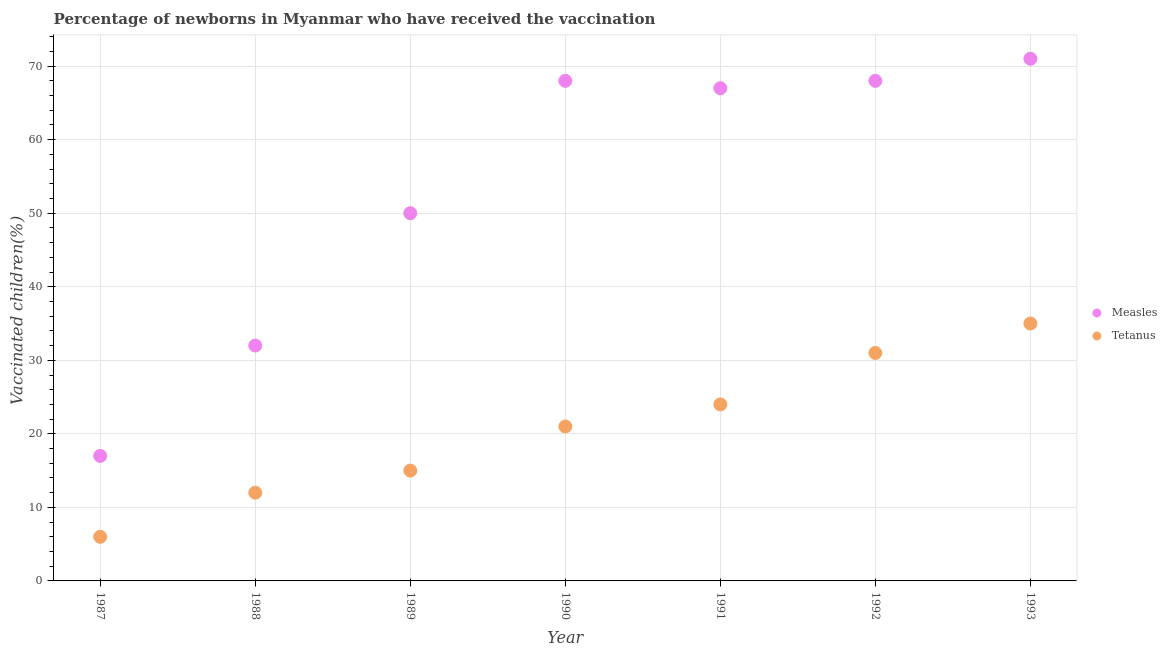How many different coloured dotlines are there?
Provide a short and direct response. 2. Is the number of dotlines equal to the number of legend labels?
Your response must be concise. Yes. What is the percentage of newborns who received vaccination for tetanus in 1987?
Provide a short and direct response. 6. Across all years, what is the maximum percentage of newborns who received vaccination for tetanus?
Offer a very short reply. 35. Across all years, what is the minimum percentage of newborns who received vaccination for tetanus?
Your response must be concise. 6. In which year was the percentage of newborns who received vaccination for tetanus maximum?
Your answer should be very brief. 1993. What is the total percentage of newborns who received vaccination for tetanus in the graph?
Give a very brief answer. 144. What is the difference between the percentage of newborns who received vaccination for measles in 1990 and that in 1991?
Keep it short and to the point. 1. What is the difference between the percentage of newborns who received vaccination for tetanus in 1990 and the percentage of newborns who received vaccination for measles in 1991?
Keep it short and to the point. -46. What is the average percentage of newborns who received vaccination for tetanus per year?
Provide a short and direct response. 20.57. In the year 1990, what is the difference between the percentage of newborns who received vaccination for tetanus and percentage of newborns who received vaccination for measles?
Provide a short and direct response. -47. What is the ratio of the percentage of newborns who received vaccination for tetanus in 1989 to that in 1990?
Offer a terse response. 0.71. Is the percentage of newborns who received vaccination for measles in 1990 less than that in 1992?
Make the answer very short. No. What is the difference between the highest and the lowest percentage of newborns who received vaccination for tetanus?
Make the answer very short. 29. In how many years, is the percentage of newborns who received vaccination for measles greater than the average percentage of newborns who received vaccination for measles taken over all years?
Provide a succinct answer. 4. Does the percentage of newborns who received vaccination for measles monotonically increase over the years?
Offer a terse response. No. Is the percentage of newborns who received vaccination for tetanus strictly greater than the percentage of newborns who received vaccination for measles over the years?
Give a very brief answer. No. Is the percentage of newborns who received vaccination for measles strictly less than the percentage of newborns who received vaccination for tetanus over the years?
Provide a short and direct response. No. What is the difference between two consecutive major ticks on the Y-axis?
Make the answer very short. 10. Where does the legend appear in the graph?
Provide a short and direct response. Center right. How many legend labels are there?
Your answer should be compact. 2. How are the legend labels stacked?
Provide a short and direct response. Vertical. What is the title of the graph?
Your answer should be compact. Percentage of newborns in Myanmar who have received the vaccination. Does "Female entrants" appear as one of the legend labels in the graph?
Provide a succinct answer. No. What is the label or title of the Y-axis?
Your answer should be compact. Vaccinated children(%)
. What is the Vaccinated children(%)
 of Measles in 1987?
Make the answer very short. 17. What is the Vaccinated children(%)
 in Tetanus in 1987?
Keep it short and to the point. 6. What is the Vaccinated children(%)
 in Measles in 1988?
Give a very brief answer. 32. What is the Vaccinated children(%)
 in Tetanus in 1989?
Make the answer very short. 15. What is the Vaccinated children(%)
 of Measles in 1990?
Your response must be concise. 68. What is the Vaccinated children(%)
 in Measles in 1991?
Provide a succinct answer. 67. What is the Vaccinated children(%)
 of Tetanus in 1991?
Your answer should be very brief. 24. Across all years, what is the minimum Vaccinated children(%)
 in Measles?
Give a very brief answer. 17. Across all years, what is the minimum Vaccinated children(%)
 in Tetanus?
Provide a short and direct response. 6. What is the total Vaccinated children(%)
 of Measles in the graph?
Your answer should be compact. 373. What is the total Vaccinated children(%)
 of Tetanus in the graph?
Make the answer very short. 144. What is the difference between the Vaccinated children(%)
 of Tetanus in 1987 and that in 1988?
Keep it short and to the point. -6. What is the difference between the Vaccinated children(%)
 in Measles in 1987 and that in 1989?
Keep it short and to the point. -33. What is the difference between the Vaccinated children(%)
 of Measles in 1987 and that in 1990?
Give a very brief answer. -51. What is the difference between the Vaccinated children(%)
 in Tetanus in 1987 and that in 1991?
Ensure brevity in your answer.  -18. What is the difference between the Vaccinated children(%)
 of Measles in 1987 and that in 1992?
Provide a succinct answer. -51. What is the difference between the Vaccinated children(%)
 in Tetanus in 1987 and that in 1992?
Make the answer very short. -25. What is the difference between the Vaccinated children(%)
 of Measles in 1987 and that in 1993?
Provide a succinct answer. -54. What is the difference between the Vaccinated children(%)
 of Measles in 1988 and that in 1990?
Provide a succinct answer. -36. What is the difference between the Vaccinated children(%)
 in Tetanus in 1988 and that in 1990?
Provide a succinct answer. -9. What is the difference between the Vaccinated children(%)
 in Measles in 1988 and that in 1991?
Offer a terse response. -35. What is the difference between the Vaccinated children(%)
 in Measles in 1988 and that in 1992?
Offer a terse response. -36. What is the difference between the Vaccinated children(%)
 in Measles in 1988 and that in 1993?
Give a very brief answer. -39. What is the difference between the Vaccinated children(%)
 in Measles in 1989 and that in 1991?
Offer a very short reply. -17. What is the difference between the Vaccinated children(%)
 in Tetanus in 1989 and that in 1991?
Your answer should be very brief. -9. What is the difference between the Vaccinated children(%)
 of Measles in 1989 and that in 1992?
Give a very brief answer. -18. What is the difference between the Vaccinated children(%)
 of Tetanus in 1989 and that in 1992?
Your answer should be very brief. -16. What is the difference between the Vaccinated children(%)
 in Measles in 1989 and that in 1993?
Your response must be concise. -21. What is the difference between the Vaccinated children(%)
 of Tetanus in 1989 and that in 1993?
Make the answer very short. -20. What is the difference between the Vaccinated children(%)
 in Measles in 1990 and that in 1991?
Offer a terse response. 1. What is the difference between the Vaccinated children(%)
 of Measles in 1990 and that in 1992?
Keep it short and to the point. 0. What is the difference between the Vaccinated children(%)
 in Tetanus in 1990 and that in 1992?
Your response must be concise. -10. What is the difference between the Vaccinated children(%)
 in Tetanus in 1990 and that in 1993?
Ensure brevity in your answer.  -14. What is the difference between the Vaccinated children(%)
 in Tetanus in 1991 and that in 1992?
Make the answer very short. -7. What is the difference between the Vaccinated children(%)
 in Tetanus in 1991 and that in 1993?
Your response must be concise. -11. What is the difference between the Vaccinated children(%)
 in Measles in 1992 and that in 1993?
Offer a very short reply. -3. What is the difference between the Vaccinated children(%)
 of Measles in 1987 and the Vaccinated children(%)
 of Tetanus in 1988?
Offer a very short reply. 5. What is the difference between the Vaccinated children(%)
 in Measles in 1987 and the Vaccinated children(%)
 in Tetanus in 1989?
Provide a succinct answer. 2. What is the difference between the Vaccinated children(%)
 in Measles in 1987 and the Vaccinated children(%)
 in Tetanus in 1990?
Offer a very short reply. -4. What is the difference between the Vaccinated children(%)
 of Measles in 1987 and the Vaccinated children(%)
 of Tetanus in 1992?
Give a very brief answer. -14. What is the difference between the Vaccinated children(%)
 of Measles in 1987 and the Vaccinated children(%)
 of Tetanus in 1993?
Provide a succinct answer. -18. What is the difference between the Vaccinated children(%)
 in Measles in 1988 and the Vaccinated children(%)
 in Tetanus in 1989?
Make the answer very short. 17. What is the difference between the Vaccinated children(%)
 of Measles in 1988 and the Vaccinated children(%)
 of Tetanus in 1992?
Make the answer very short. 1. What is the difference between the Vaccinated children(%)
 in Measles in 1989 and the Vaccinated children(%)
 in Tetanus in 1991?
Make the answer very short. 26. What is the difference between the Vaccinated children(%)
 in Measles in 1990 and the Vaccinated children(%)
 in Tetanus in 1992?
Your response must be concise. 37. What is the difference between the Vaccinated children(%)
 of Measles in 1990 and the Vaccinated children(%)
 of Tetanus in 1993?
Make the answer very short. 33. What is the difference between the Vaccinated children(%)
 of Measles in 1992 and the Vaccinated children(%)
 of Tetanus in 1993?
Offer a very short reply. 33. What is the average Vaccinated children(%)
 of Measles per year?
Provide a succinct answer. 53.29. What is the average Vaccinated children(%)
 of Tetanus per year?
Offer a very short reply. 20.57. In the year 1987, what is the difference between the Vaccinated children(%)
 in Measles and Vaccinated children(%)
 in Tetanus?
Provide a short and direct response. 11. In the year 1989, what is the difference between the Vaccinated children(%)
 of Measles and Vaccinated children(%)
 of Tetanus?
Ensure brevity in your answer.  35. In the year 1992, what is the difference between the Vaccinated children(%)
 in Measles and Vaccinated children(%)
 in Tetanus?
Your response must be concise. 37. What is the ratio of the Vaccinated children(%)
 in Measles in 1987 to that in 1988?
Give a very brief answer. 0.53. What is the ratio of the Vaccinated children(%)
 in Tetanus in 1987 to that in 1988?
Your answer should be compact. 0.5. What is the ratio of the Vaccinated children(%)
 of Measles in 1987 to that in 1989?
Make the answer very short. 0.34. What is the ratio of the Vaccinated children(%)
 in Tetanus in 1987 to that in 1990?
Make the answer very short. 0.29. What is the ratio of the Vaccinated children(%)
 in Measles in 1987 to that in 1991?
Offer a very short reply. 0.25. What is the ratio of the Vaccinated children(%)
 in Tetanus in 1987 to that in 1991?
Offer a very short reply. 0.25. What is the ratio of the Vaccinated children(%)
 in Tetanus in 1987 to that in 1992?
Give a very brief answer. 0.19. What is the ratio of the Vaccinated children(%)
 of Measles in 1987 to that in 1993?
Keep it short and to the point. 0.24. What is the ratio of the Vaccinated children(%)
 of Tetanus in 1987 to that in 1993?
Offer a very short reply. 0.17. What is the ratio of the Vaccinated children(%)
 in Measles in 1988 to that in 1989?
Offer a terse response. 0.64. What is the ratio of the Vaccinated children(%)
 in Measles in 1988 to that in 1990?
Provide a succinct answer. 0.47. What is the ratio of the Vaccinated children(%)
 in Measles in 1988 to that in 1991?
Give a very brief answer. 0.48. What is the ratio of the Vaccinated children(%)
 in Measles in 1988 to that in 1992?
Your response must be concise. 0.47. What is the ratio of the Vaccinated children(%)
 in Tetanus in 1988 to that in 1992?
Your answer should be very brief. 0.39. What is the ratio of the Vaccinated children(%)
 in Measles in 1988 to that in 1993?
Keep it short and to the point. 0.45. What is the ratio of the Vaccinated children(%)
 in Tetanus in 1988 to that in 1993?
Offer a very short reply. 0.34. What is the ratio of the Vaccinated children(%)
 of Measles in 1989 to that in 1990?
Provide a succinct answer. 0.74. What is the ratio of the Vaccinated children(%)
 of Tetanus in 1989 to that in 1990?
Offer a very short reply. 0.71. What is the ratio of the Vaccinated children(%)
 of Measles in 1989 to that in 1991?
Keep it short and to the point. 0.75. What is the ratio of the Vaccinated children(%)
 of Tetanus in 1989 to that in 1991?
Provide a succinct answer. 0.62. What is the ratio of the Vaccinated children(%)
 in Measles in 1989 to that in 1992?
Your answer should be compact. 0.74. What is the ratio of the Vaccinated children(%)
 in Tetanus in 1989 to that in 1992?
Provide a succinct answer. 0.48. What is the ratio of the Vaccinated children(%)
 in Measles in 1989 to that in 1993?
Ensure brevity in your answer.  0.7. What is the ratio of the Vaccinated children(%)
 of Tetanus in 1989 to that in 1993?
Ensure brevity in your answer.  0.43. What is the ratio of the Vaccinated children(%)
 of Measles in 1990 to that in 1991?
Make the answer very short. 1.01. What is the ratio of the Vaccinated children(%)
 of Measles in 1990 to that in 1992?
Provide a succinct answer. 1. What is the ratio of the Vaccinated children(%)
 in Tetanus in 1990 to that in 1992?
Offer a terse response. 0.68. What is the ratio of the Vaccinated children(%)
 in Measles in 1990 to that in 1993?
Your answer should be very brief. 0.96. What is the ratio of the Vaccinated children(%)
 of Measles in 1991 to that in 1992?
Ensure brevity in your answer.  0.99. What is the ratio of the Vaccinated children(%)
 of Tetanus in 1991 to that in 1992?
Make the answer very short. 0.77. What is the ratio of the Vaccinated children(%)
 of Measles in 1991 to that in 1993?
Offer a very short reply. 0.94. What is the ratio of the Vaccinated children(%)
 of Tetanus in 1991 to that in 1993?
Give a very brief answer. 0.69. What is the ratio of the Vaccinated children(%)
 in Measles in 1992 to that in 1993?
Make the answer very short. 0.96. What is the ratio of the Vaccinated children(%)
 in Tetanus in 1992 to that in 1993?
Ensure brevity in your answer.  0.89. What is the difference between the highest and the second highest Vaccinated children(%)
 in Measles?
Offer a very short reply. 3. What is the difference between the highest and the second highest Vaccinated children(%)
 in Tetanus?
Offer a very short reply. 4. What is the difference between the highest and the lowest Vaccinated children(%)
 of Measles?
Ensure brevity in your answer.  54. What is the difference between the highest and the lowest Vaccinated children(%)
 in Tetanus?
Your answer should be compact. 29. 